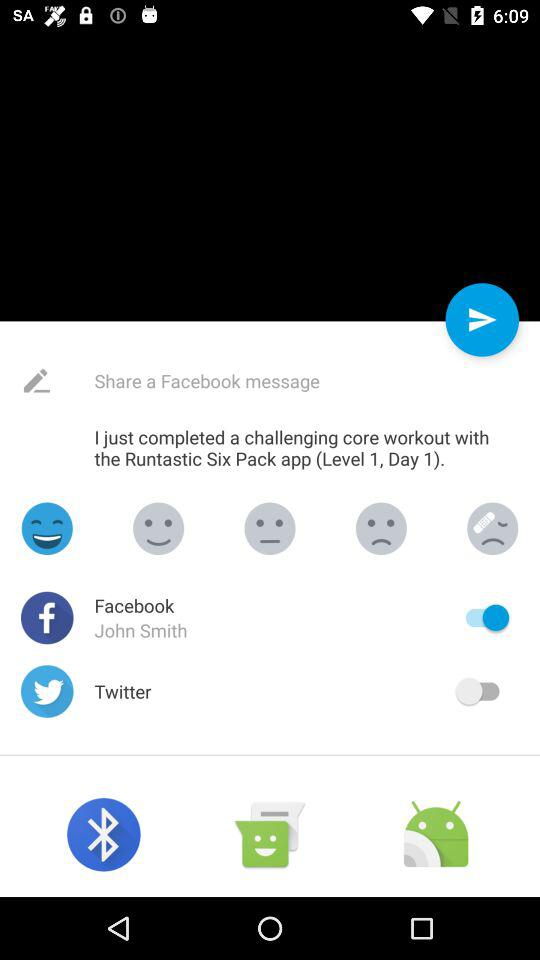What applications can be used to share a message? The applications are "Facebook" and "Twitter". 